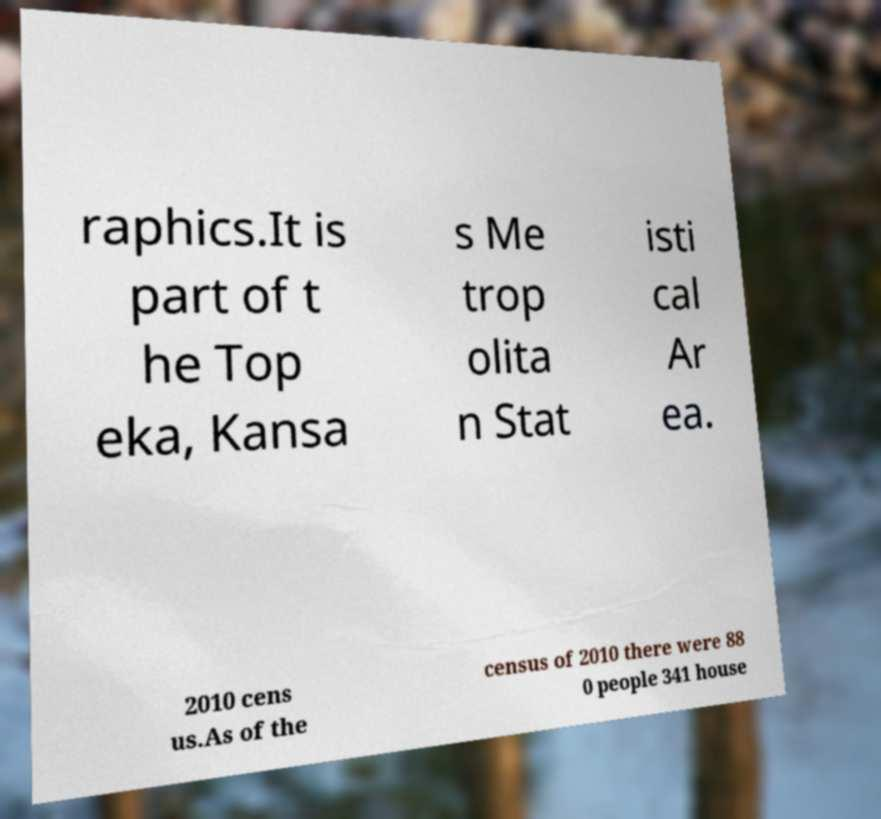Can you read and provide the text displayed in the image?This photo seems to have some interesting text. Can you extract and type it out for me? raphics.It is part of t he Top eka, Kansa s Me trop olita n Stat isti cal Ar ea. 2010 cens us.As of the census of 2010 there were 88 0 people 341 house 